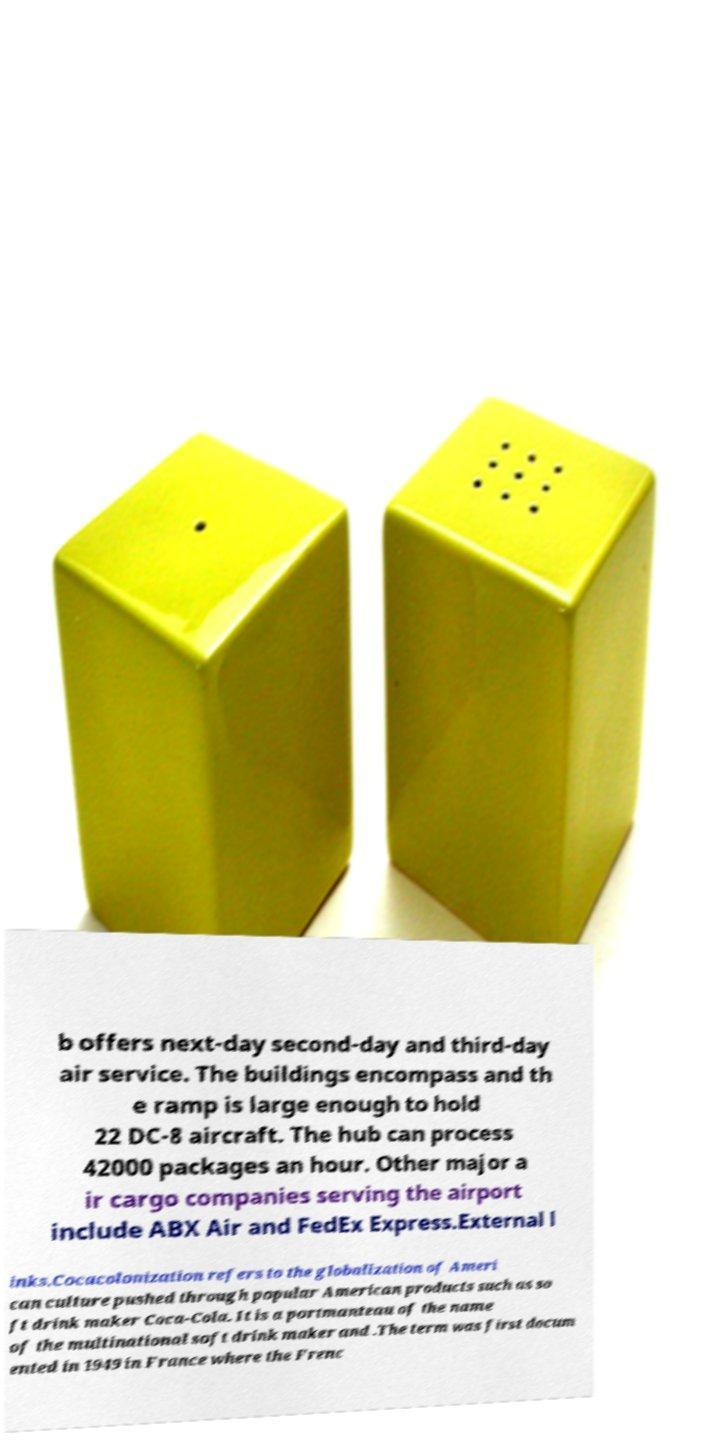What messages or text are displayed in this image? I need them in a readable, typed format. b offers next-day second-day and third-day air service. The buildings encompass and th e ramp is large enough to hold 22 DC-8 aircraft. The hub can process 42000 packages an hour. Other major a ir cargo companies serving the airport include ABX Air and FedEx Express.External l inks.Cocacolonization refers to the globalization of Ameri can culture pushed through popular American products such as so ft drink maker Coca-Cola. It is a portmanteau of the name of the multinational soft drink maker and .The term was first docum ented in 1949 in France where the Frenc 